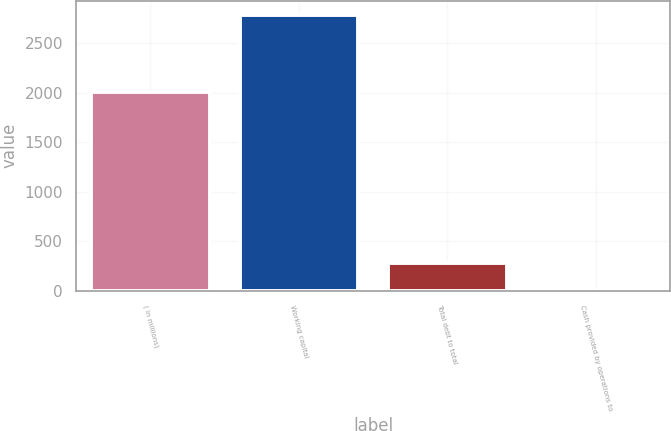Convert chart to OTSL. <chart><loc_0><loc_0><loc_500><loc_500><bar_chart><fcel>( in millions)<fcel>Working capital<fcel>Total debt to total<fcel>Cash provided by operations to<nl><fcel>2007<fcel>2787.2<fcel>279.81<fcel>1.21<nl></chart> 